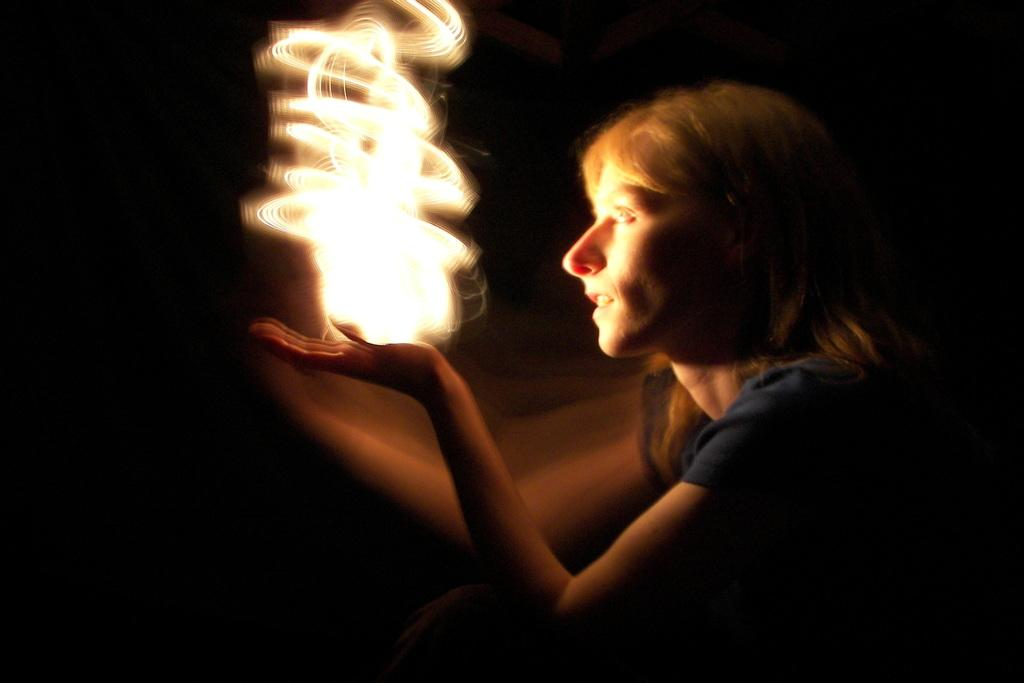Who is the main subject in the foreground of the image? There is a woman in the foreground of the image. What is the woman holding in her hand? The woman is holding a light. What is the color of the background in the image? The background of the image is black. What type of substance is the monkey using to plough the field in the image? There is no monkey or plough present in the image. 